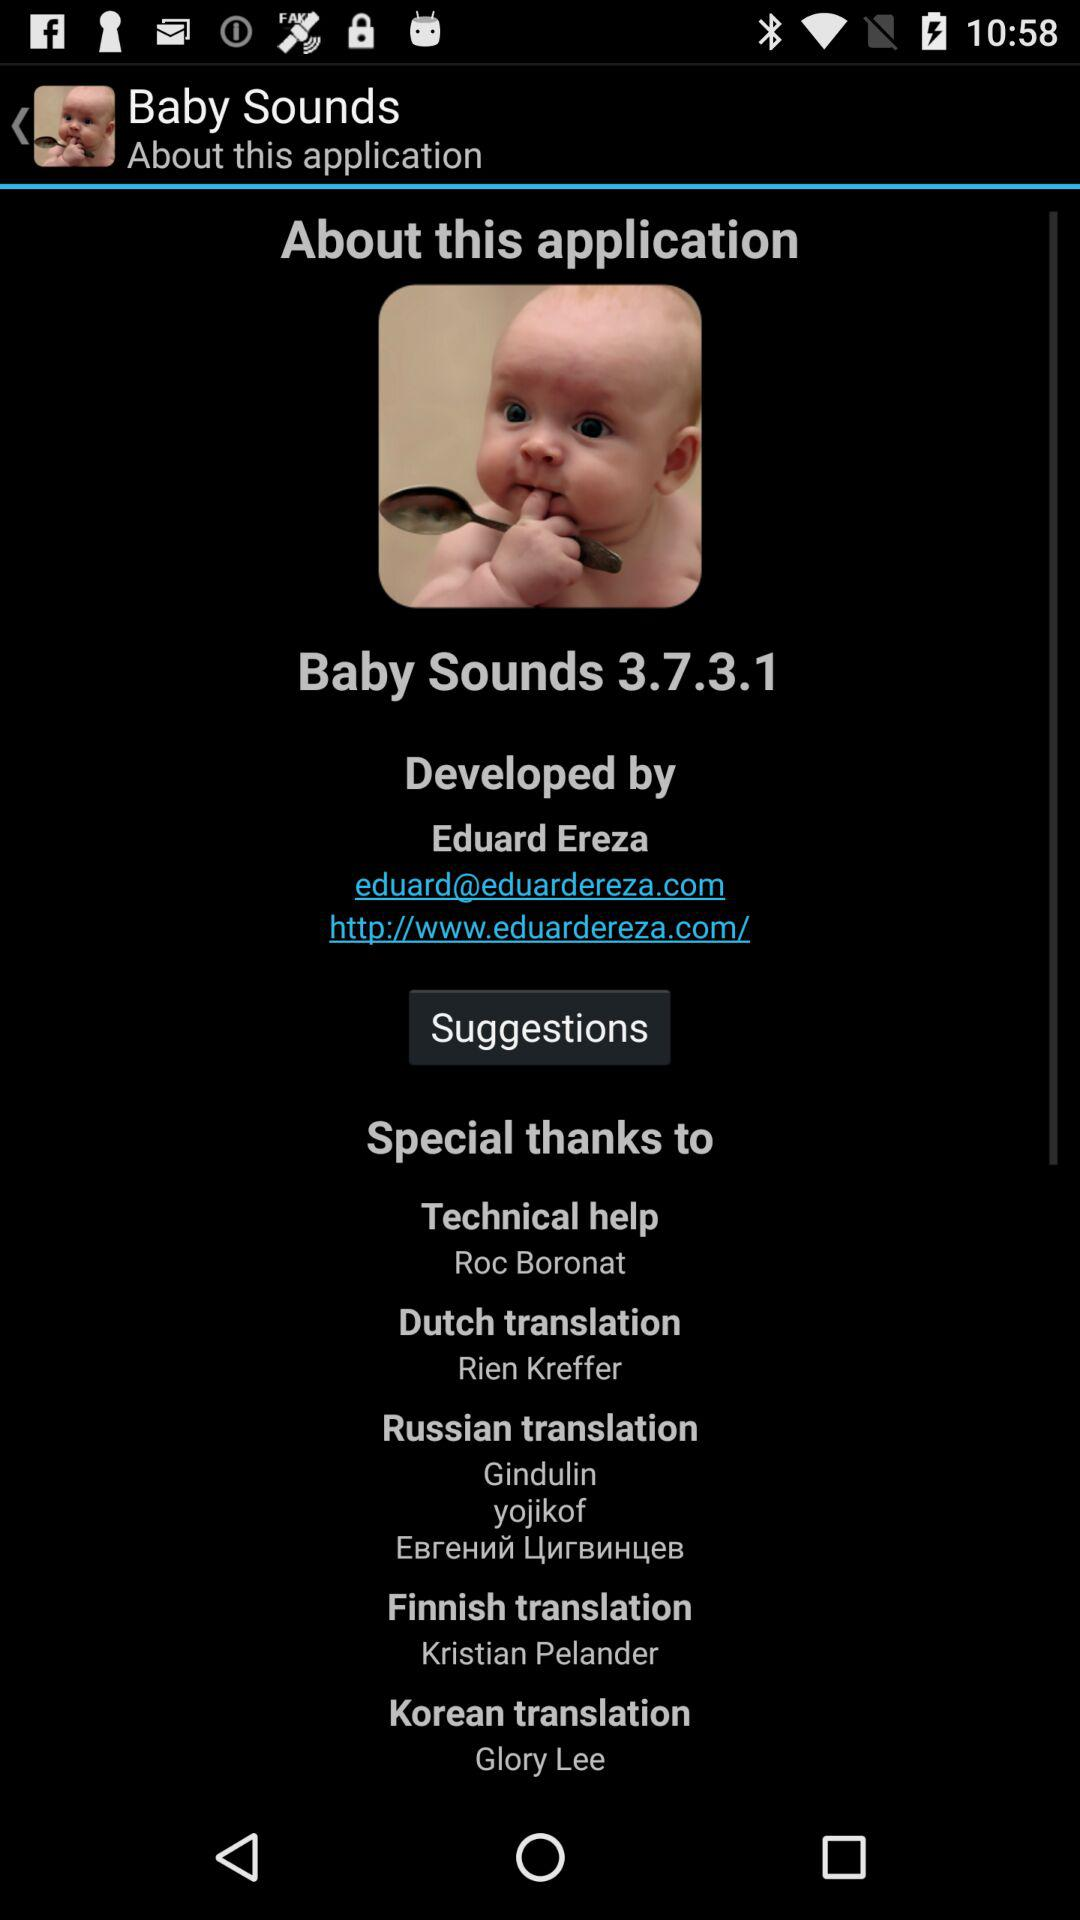What is the email address? The email address is eduard@eduardereza.com. 